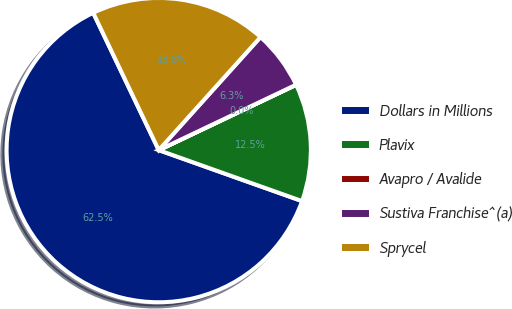Convert chart. <chart><loc_0><loc_0><loc_500><loc_500><pie_chart><fcel>Dollars in Millions<fcel>Plavix<fcel>Avapro / Avalide<fcel>Sustiva Franchise^(a)<fcel>Sprycel<nl><fcel>62.47%<fcel>12.5%<fcel>0.01%<fcel>6.26%<fcel>18.75%<nl></chart> 